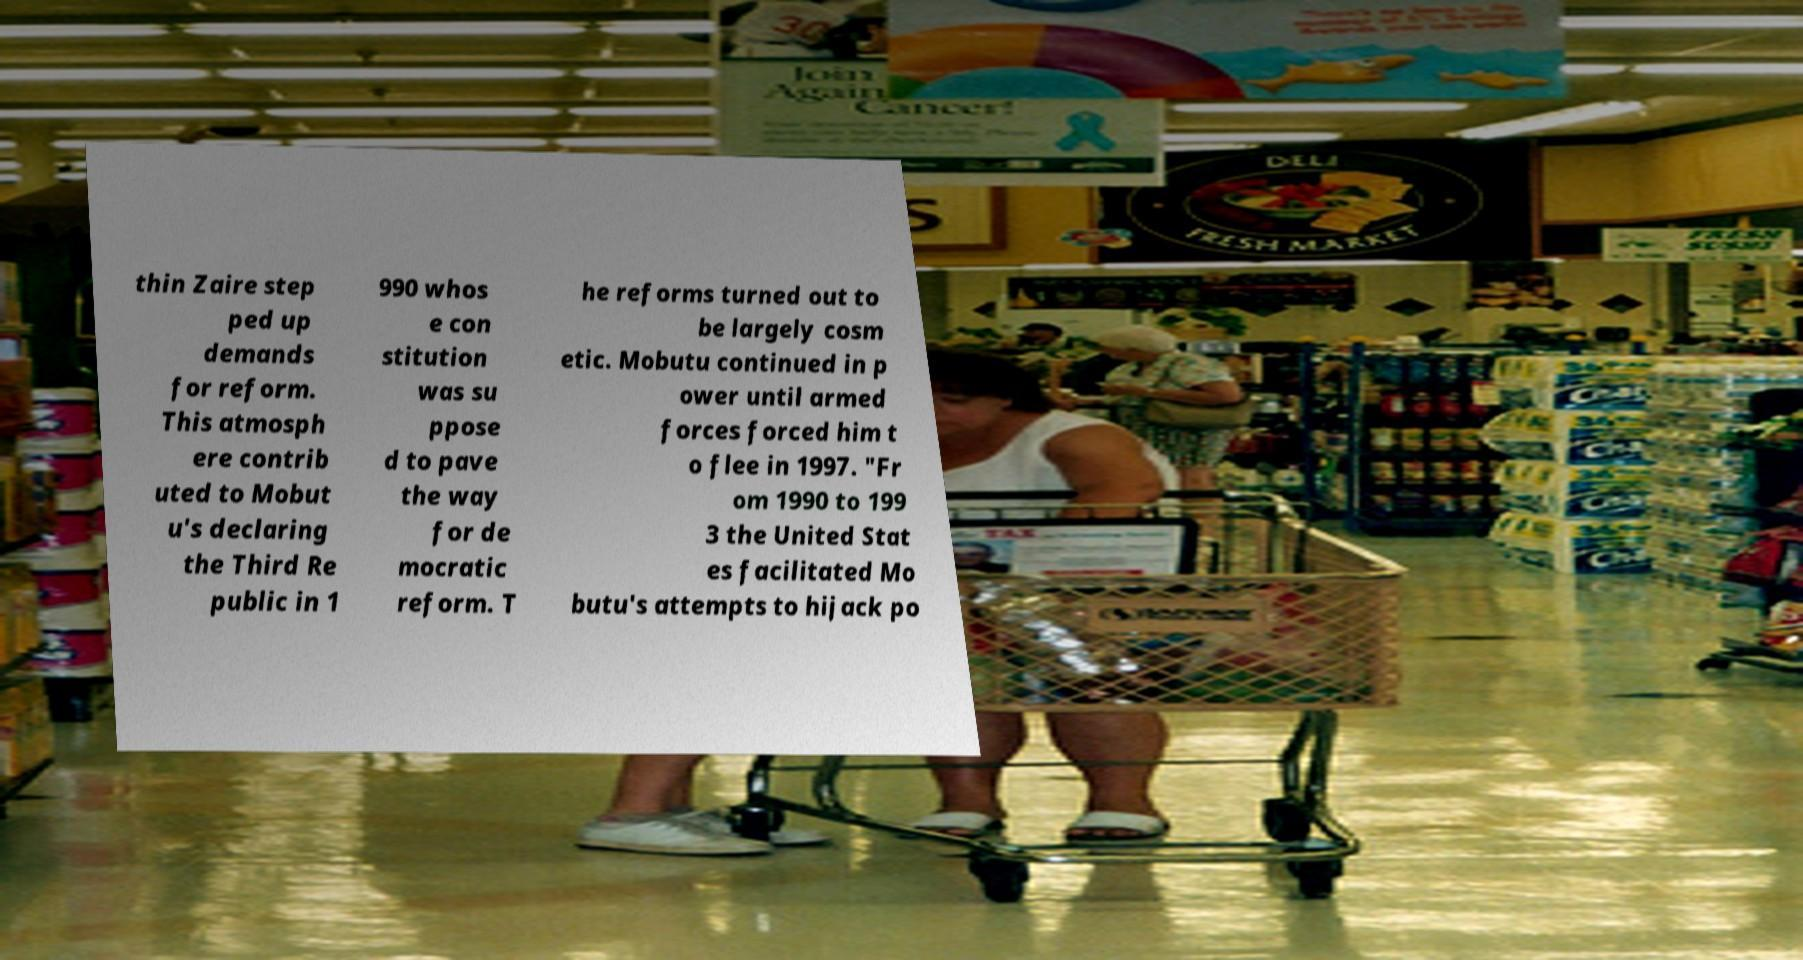Could you extract and type out the text from this image? thin Zaire step ped up demands for reform. This atmosph ere contrib uted to Mobut u's declaring the Third Re public in 1 990 whos e con stitution was su ppose d to pave the way for de mocratic reform. T he reforms turned out to be largely cosm etic. Mobutu continued in p ower until armed forces forced him t o flee in 1997. "Fr om 1990 to 199 3 the United Stat es facilitated Mo butu's attempts to hijack po 